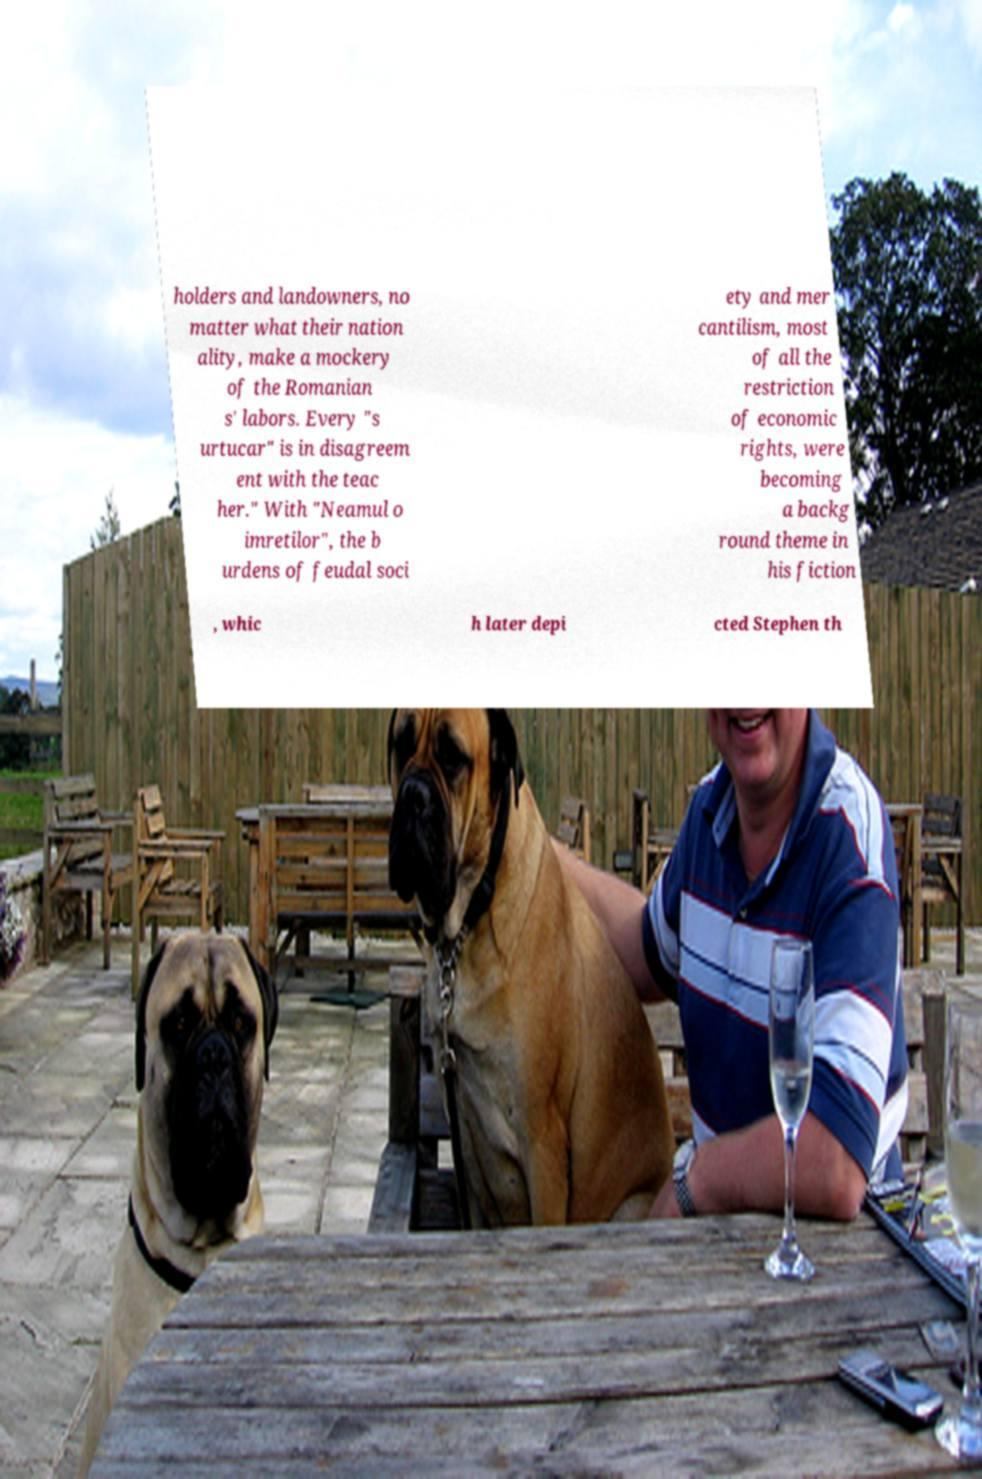Please identify and transcribe the text found in this image. holders and landowners, no matter what their nation ality, make a mockery of the Romanian s' labors. Every "s urtucar" is in disagreem ent with the teac her." With "Neamul o imretilor", the b urdens of feudal soci ety and mer cantilism, most of all the restriction of economic rights, were becoming a backg round theme in his fiction , whic h later depi cted Stephen th 